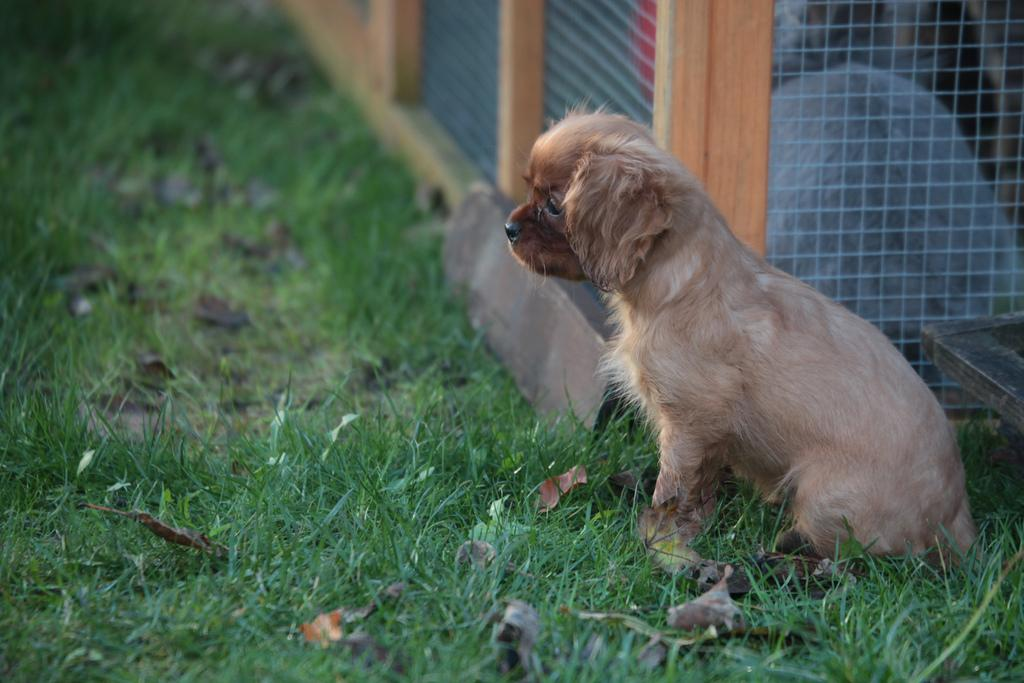What type of animal can be seen on the ground in the image? There is a dog on the ground in the image. What type of vegetation is present in the image? There are dried leaves and grass visible in the image. What material is the grill made of in the image? The grill in the image is made of metal. What type of fruit is hanging from the tree in the image? There is no tree or fruit present in the image. What type of fowl can be seen in the image? There is no fowl present in the image. 